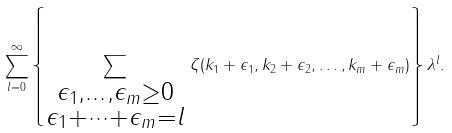Convert formula to latex. <formula><loc_0><loc_0><loc_500><loc_500>\sum _ { l = 0 } ^ { \infty } \left \{ \sum _ { \substack { \epsilon _ { 1 } , \dots , \epsilon _ { m } \geq 0 \\ \epsilon _ { 1 } + \dots + \epsilon _ { m } = l } } \, \zeta ( k _ { 1 } + \epsilon _ { 1 } , k _ { 2 } + \epsilon _ { 2 } , \dots , k _ { m } + \epsilon _ { m } ) \right \} \lambda ^ { l } .</formula> 